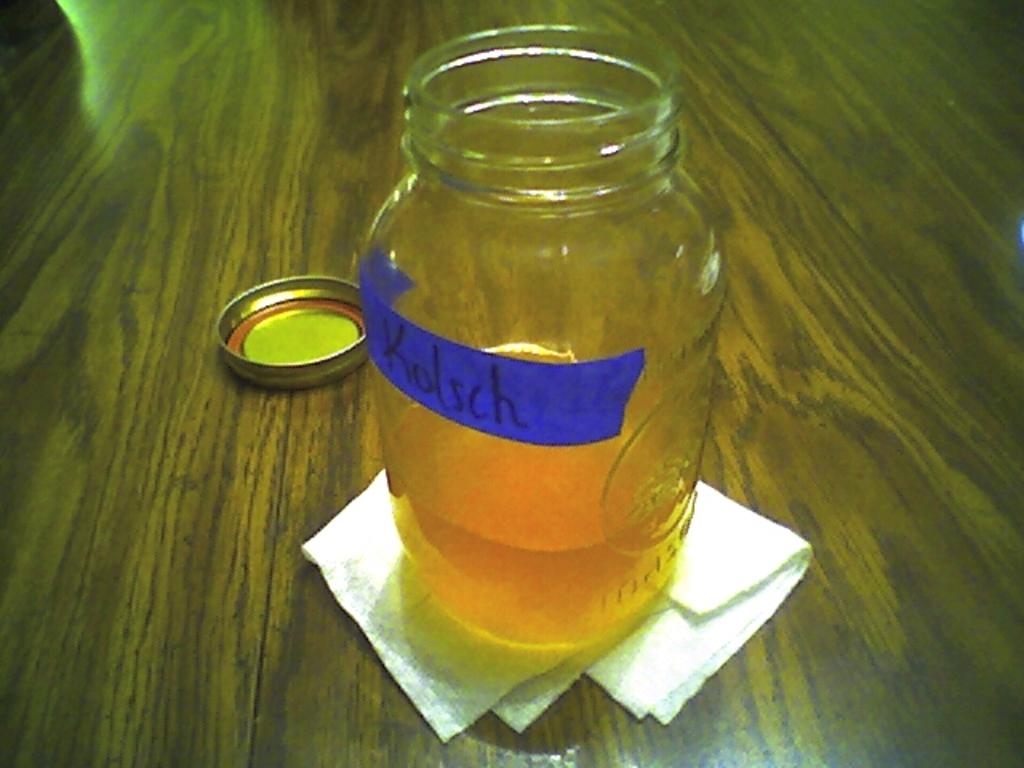<image>
Offer a succinct explanation of the picture presented. A jar has been labeled Kolsch with blue tape. 